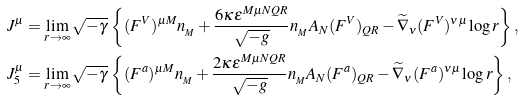<formula> <loc_0><loc_0><loc_500><loc_500>& J ^ { \mu } = \lim _ { r \to \infty } \sqrt { - \gamma } \, \left \{ ( F ^ { V } ) ^ { \mu M } n _ { _ { M } } + \frac { 6 \kappa \epsilon ^ { M \mu N Q R } } { \sqrt { - g } } n _ { _ { M } } A _ { N } ( F ^ { V } ) _ { Q R } - \widetilde { \nabla } _ { \nu } ( F ^ { V } ) ^ { \nu \mu } \log r \right \} , \\ & J _ { 5 } ^ { \mu } = \lim _ { r \to \infty } \sqrt { - \gamma } \, \left \{ ( F ^ { a } ) ^ { \mu M } n _ { _ { M } } + \frac { 2 \kappa \epsilon ^ { M \mu N Q R } } { \sqrt { - g } } n _ { _ { M } } A _ { N } ( F ^ { a } ) _ { Q R } - \widetilde { \nabla } _ { \nu } ( F ^ { a } ) ^ { \nu \mu } \log r \right \} ,</formula> 